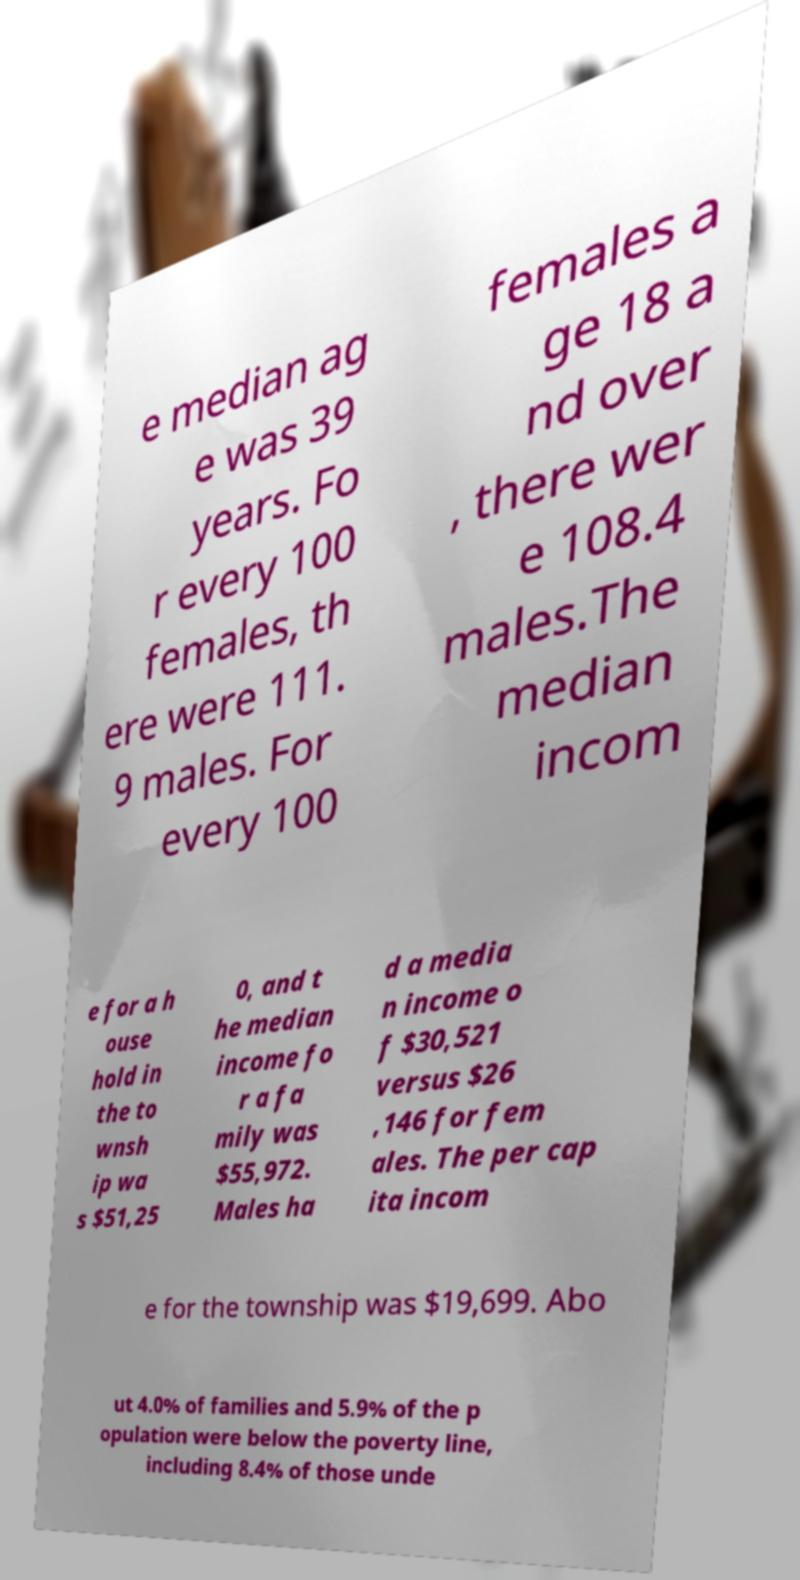Can you accurately transcribe the text from the provided image for me? e median ag e was 39 years. Fo r every 100 females, th ere were 111. 9 males. For every 100 females a ge 18 a nd over , there wer e 108.4 males.The median incom e for a h ouse hold in the to wnsh ip wa s $51,25 0, and t he median income fo r a fa mily was $55,972. Males ha d a media n income o f $30,521 versus $26 ,146 for fem ales. The per cap ita incom e for the township was $19,699. Abo ut 4.0% of families and 5.9% of the p opulation were below the poverty line, including 8.4% of those unde 